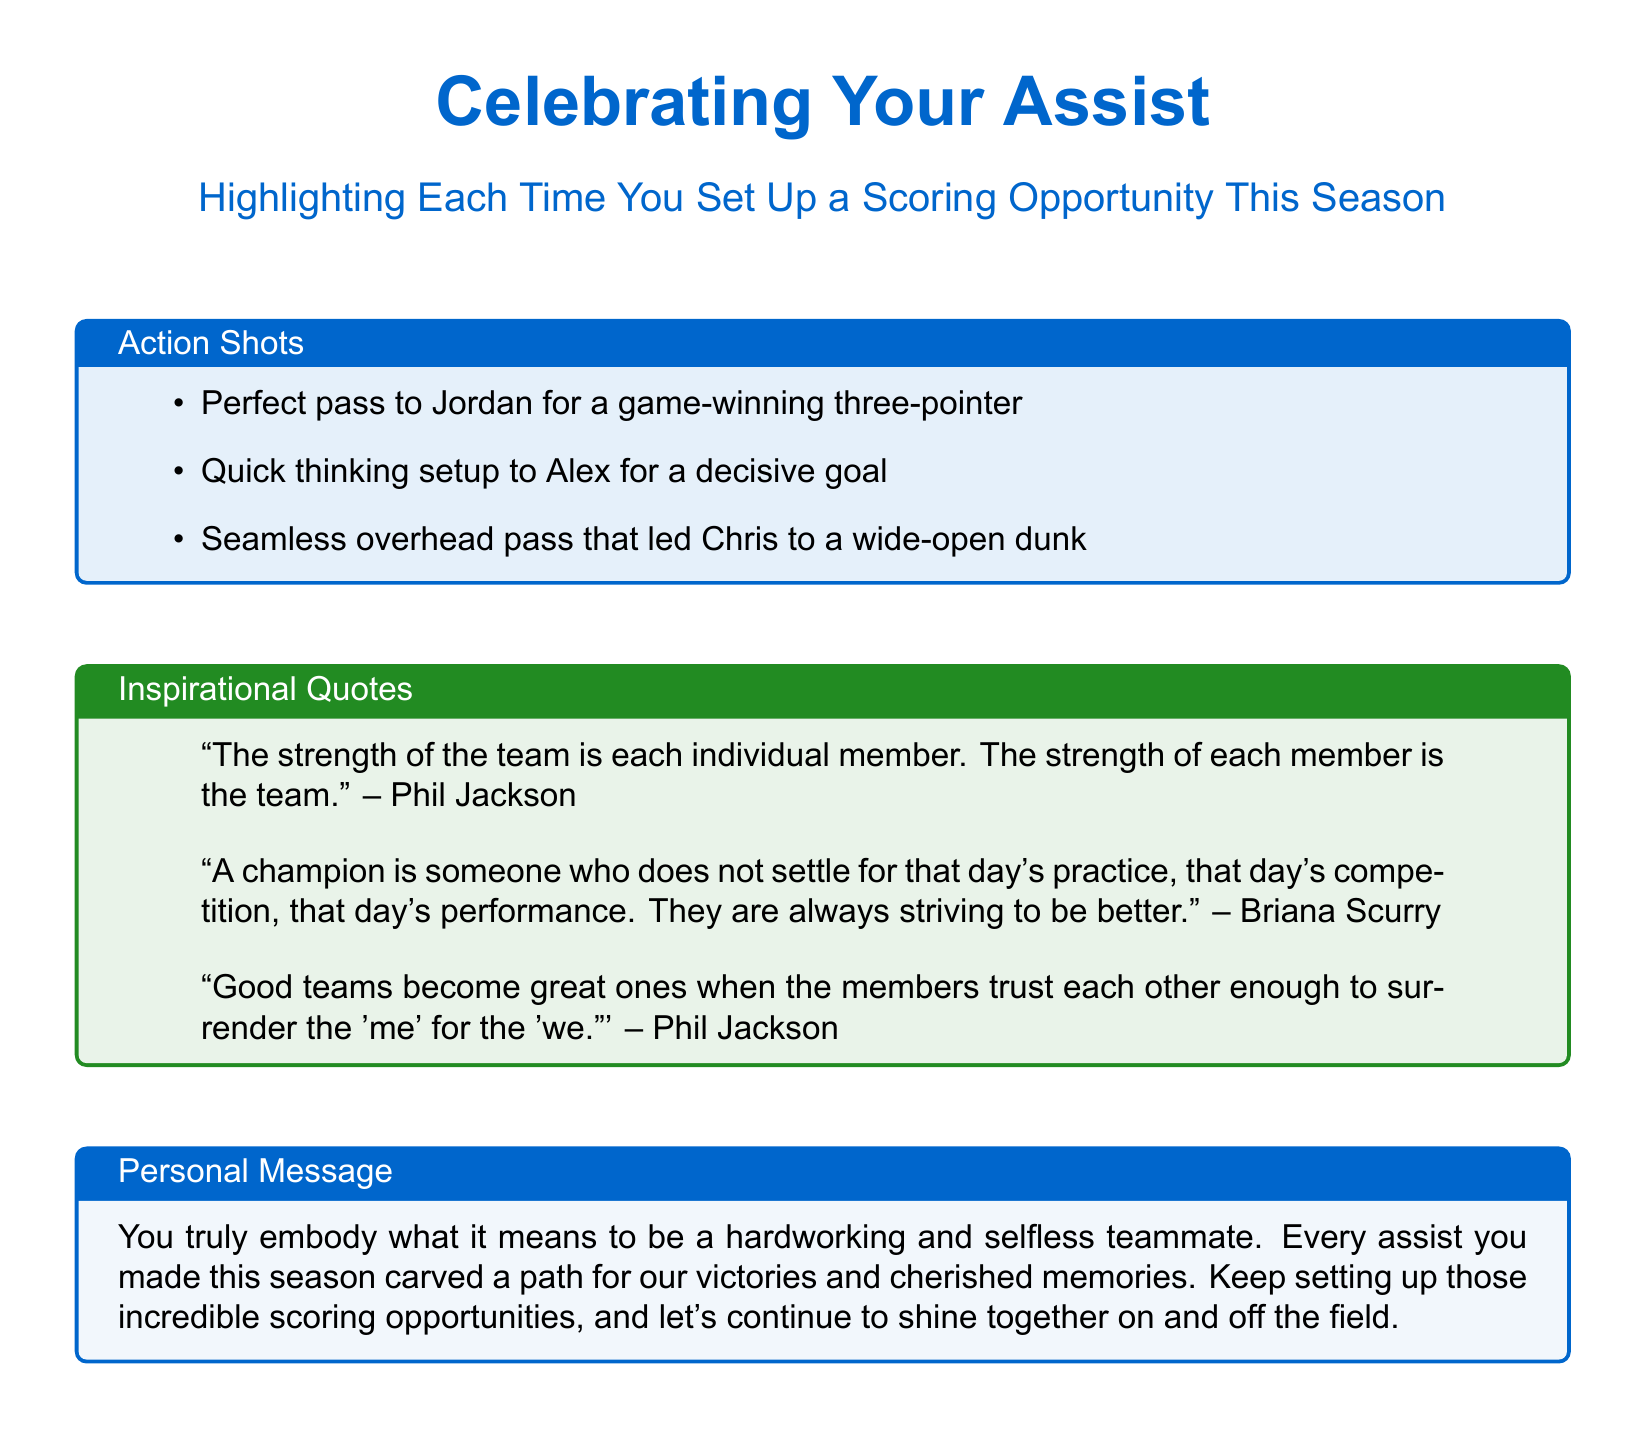What is the main title of the card? The main title of the card is prominently displayed at the top of the document.
Answer: Celebrating Your Assist How many action shots are listed? The document contains a list of action shots that highlight assists made during the season.
Answer: Three Who is credited with the quote about the strength of the team? The document attributes a quote to a well-known basketball coach regarding teamwork.
Answer: Phil Jackson What type of message does the card include? The card includes a personal message emphasizing teamwork and assist achievements.
Answer: Personal Message What is one of the quotes mentioned in the inspirational quotes section? The document includes several quotes, with one being particularly famous about teamwork.
Answer: "Good teams become great ones when the members trust each other enough to surrender the 'me' for the 'we.'" Which athlete received a perfect pass for a three-pointer? The document provides specific examples of assists and the athletes involved.
Answer: Jordan What color is used for the action shots box? The document specifies the color theme for the action shots section clearly.
Answer: Assist blue What does the card highlight about the season? The primary focus of the card is about the assists made during the season.
Answer: Scoring Opportunities Who is credited with the quote about a champion? One of the quotes talks about the nature of a champion.
Answer: Briana Scurry 